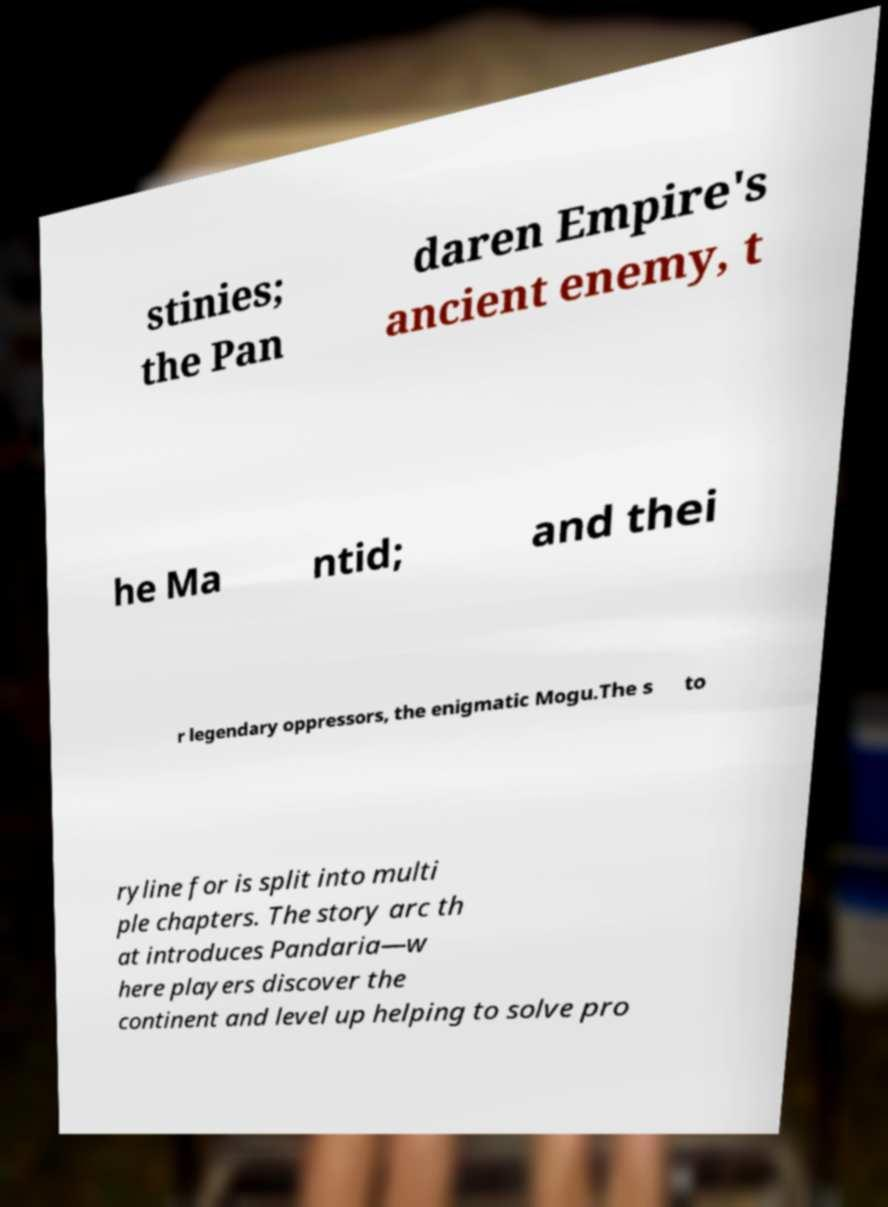Could you assist in decoding the text presented in this image and type it out clearly? stinies; the Pan daren Empire's ancient enemy, t he Ma ntid; and thei r legendary oppressors, the enigmatic Mogu.The s to ryline for is split into multi ple chapters. The story arc th at introduces Pandaria—w here players discover the continent and level up helping to solve pro 